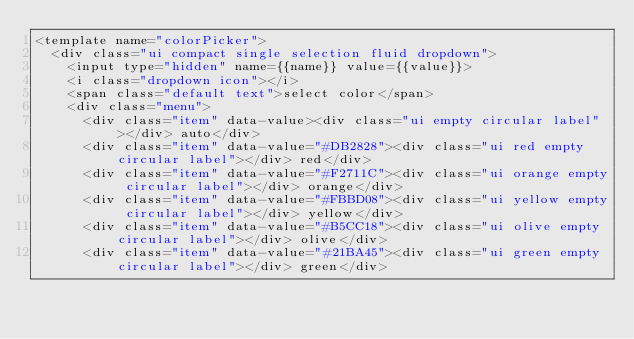<code> <loc_0><loc_0><loc_500><loc_500><_HTML_><template name="colorPicker">
  <div class="ui compact single selection fluid dropdown">
    <input type="hidden" name={{name}} value={{value}}>
    <i class="dropdown icon"></i>
    <span class="default text">select color</span>
    <div class="menu">
      <div class="item" data-value><div class="ui empty circular label"></div> auto</div>
      <div class="item" data-value="#DB2828"><div class="ui red empty circular label"></div> red</div>
      <div class="item" data-value="#F2711C"><div class="ui orange empty circular label"></div> orange</div>
      <div class="item" data-value="#FBBD08"><div class="ui yellow empty circular label"></div> yellow</div>
      <div class="item" data-value="#B5CC18"><div class="ui olive empty circular label"></div> olive</div>
      <div class="item" data-value="#21BA45"><div class="ui green empty circular label"></div> green</div></code> 